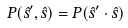<formula> <loc_0><loc_0><loc_500><loc_500>P ( \hat { s } ^ { \prime } , \hat { s } ) = P ( \hat { s } ^ { \prime } \cdot \hat { s } )</formula> 